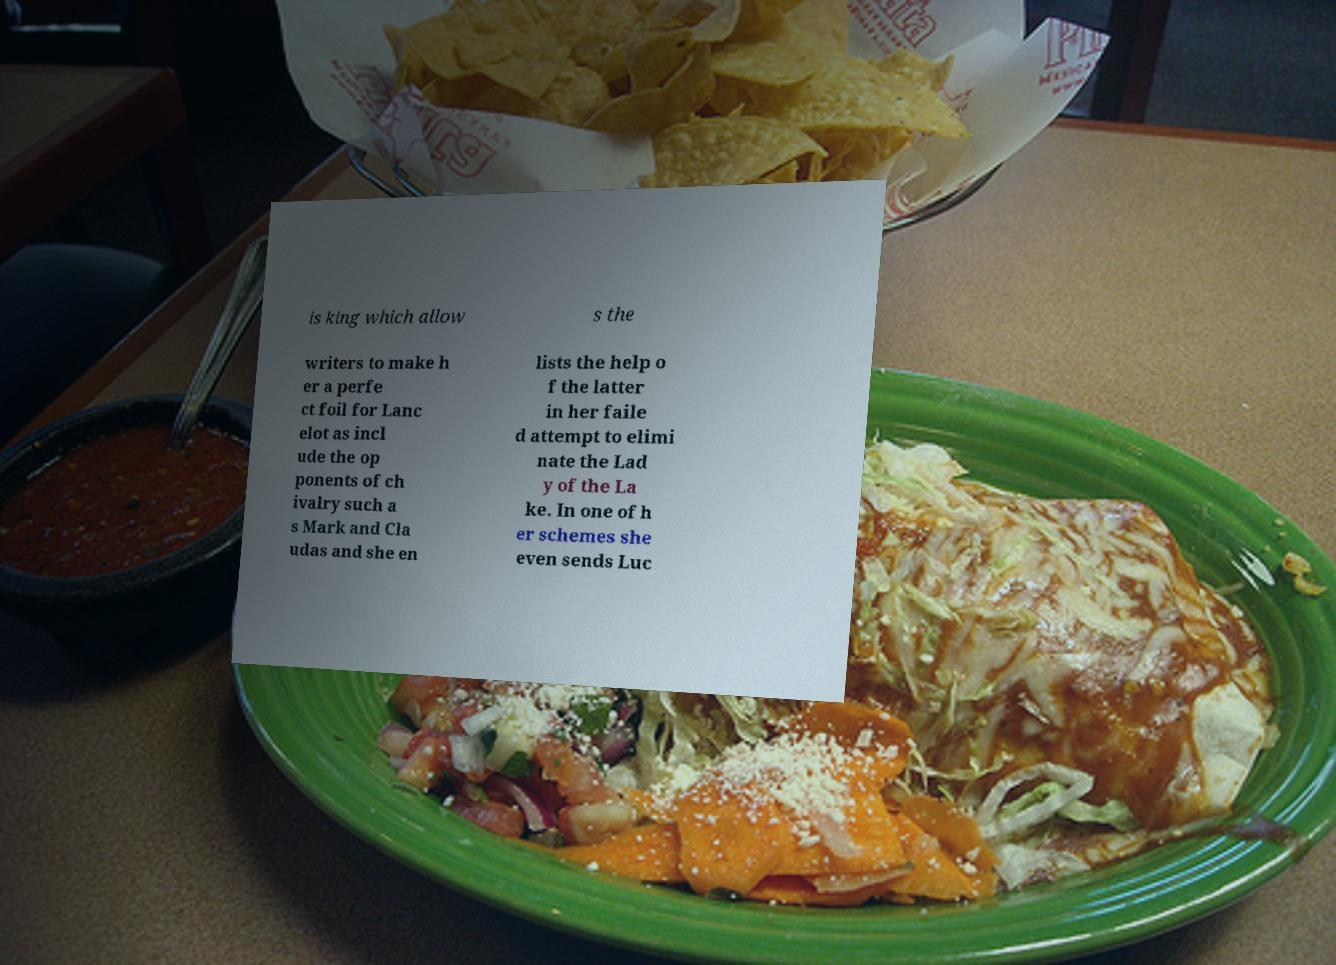Please read and relay the text visible in this image. What does it say? is king which allow s the writers to make h er a perfe ct foil for Lanc elot as incl ude the op ponents of ch ivalry such a s Mark and Cla udas and she en lists the help o f the latter in her faile d attempt to elimi nate the Lad y of the La ke. In one of h er schemes she even sends Luc 